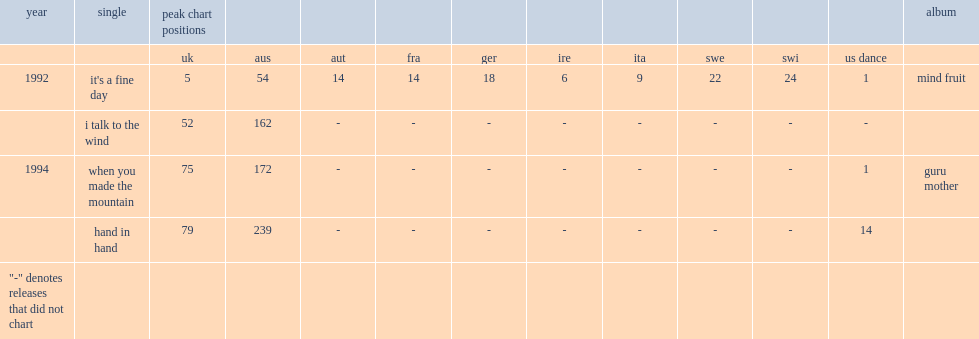What was the peak chart position on the uk of "it's a fine day"? 5.0. 